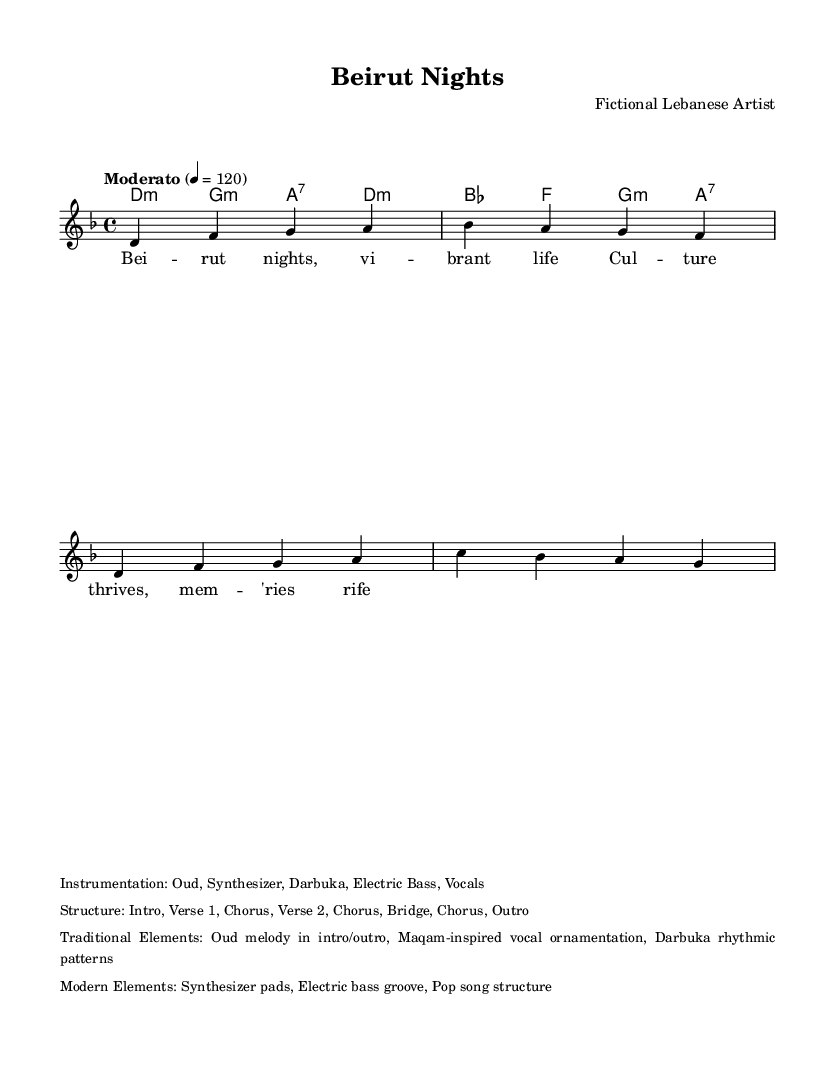What is the key signature of this music? The key signature is D minor, which includes one flat, B♭. This information comes from the global settings at the beginning of the score.
Answer: D minor What is the time signature of the piece? The time signature is 4/4, indicated in the global settings as well. This means there are four beats in each measure.
Answer: 4/4 What is the tempo marking for the piece? The tempo marking is "Moderato," which indicates a moderate speed; it is further specified to be 120 beats per minute. This is found in the global block of the score.
Answer: Moderato How many verses are in the structure of the song? The structure lists the sections as Intro, Verse 1, Chorus, Verse 2, Chorus, Bridge, Chorus, and Outro. Counting the verses, there are two verses in total: Verse 1 and Verse 2.
Answer: 2 What traditional element is included in the instrumentation? The instrumentation includes the Oud, which is a traditional Lebanese instrument frequently used in Eastern music, as noted under the instrumentation section.
Answer: Oud What modern element can be found in this composition? The score includes a Synthesizer, which is a modern instrument commonly used in pop music, mentioned in the instrumentation markup.
Answer: Synthesizer Which rhythmic pattern is mentioned as a traditional element? The rhythmic pattern is from the Darbuka, a traditional percussion instrument in Lebanese music, which is listed under the traditional elements.
Answer: Darbuka 